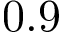<formula> <loc_0><loc_0><loc_500><loc_500>0 . 9</formula> 